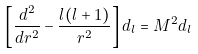<formula> <loc_0><loc_0><loc_500><loc_500>\left [ { \frac { d ^ { 2 } } { d r ^ { 2 } } } - { \frac { l ( l + 1 ) } { r ^ { 2 } } } \right ] d _ { l } = M ^ { 2 } d _ { l }</formula> 